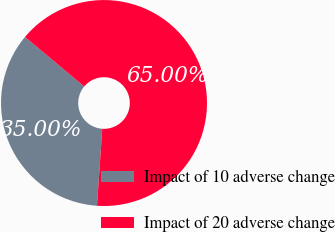Convert chart to OTSL. <chart><loc_0><loc_0><loc_500><loc_500><pie_chart><fcel>Impact of 10 adverse change<fcel>Impact of 20 adverse change<nl><fcel>35.0%<fcel>65.0%<nl></chart> 